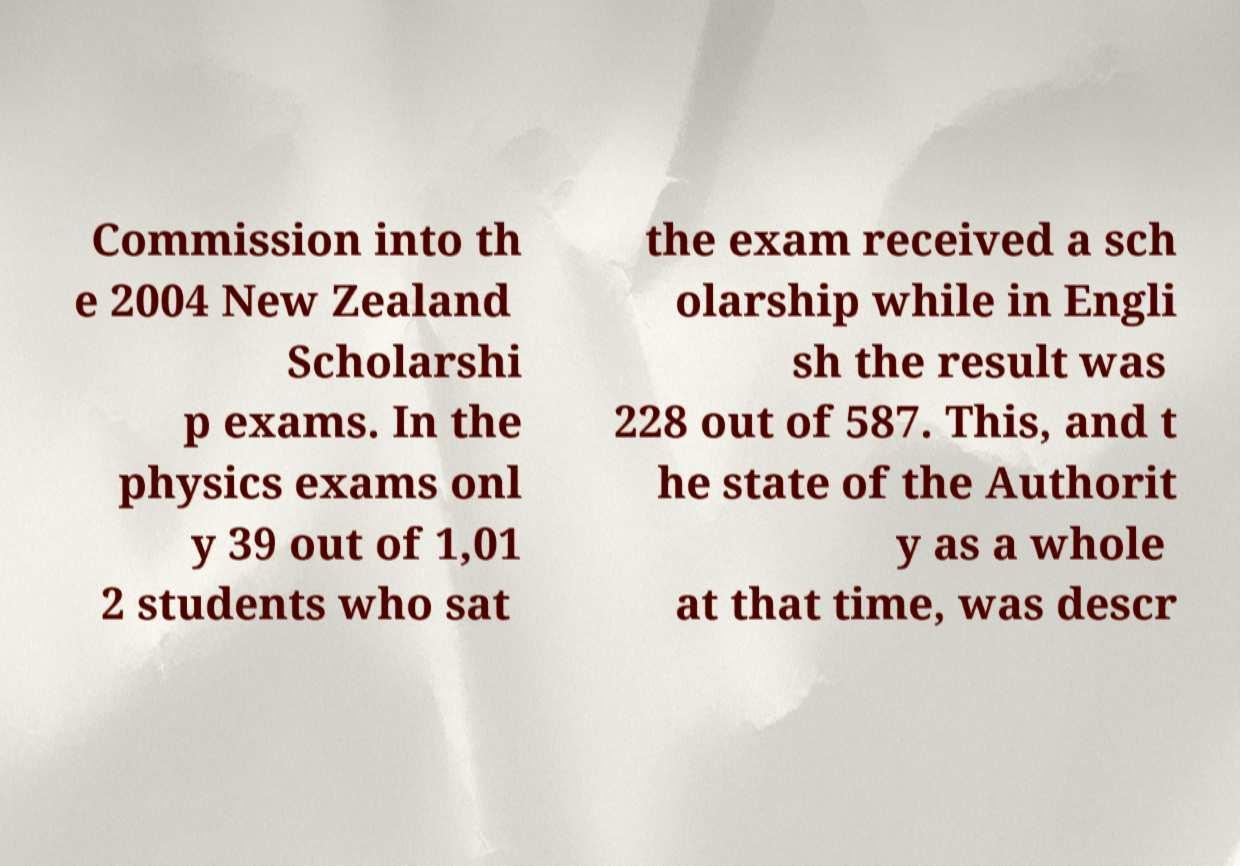Can you accurately transcribe the text from the provided image for me? Commission into th e 2004 New Zealand Scholarshi p exams. In the physics exams onl y 39 out of 1,01 2 students who sat the exam received a sch olarship while in Engli sh the result was 228 out of 587. This, and t he state of the Authorit y as a whole at that time, was descr 